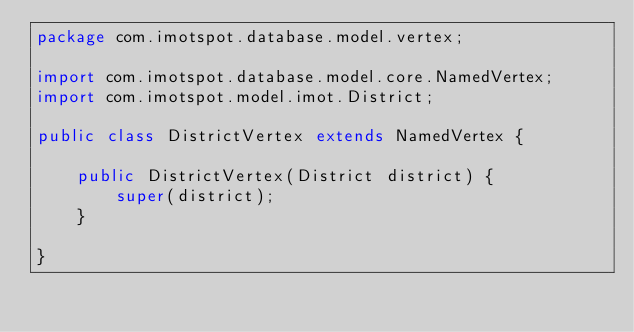<code> <loc_0><loc_0><loc_500><loc_500><_Java_>package com.imotspot.database.model.vertex;

import com.imotspot.database.model.core.NamedVertex;
import com.imotspot.model.imot.District;

public class DistrictVertex extends NamedVertex {

    public DistrictVertex(District district) {
        super(district);
    }

}
</code> 